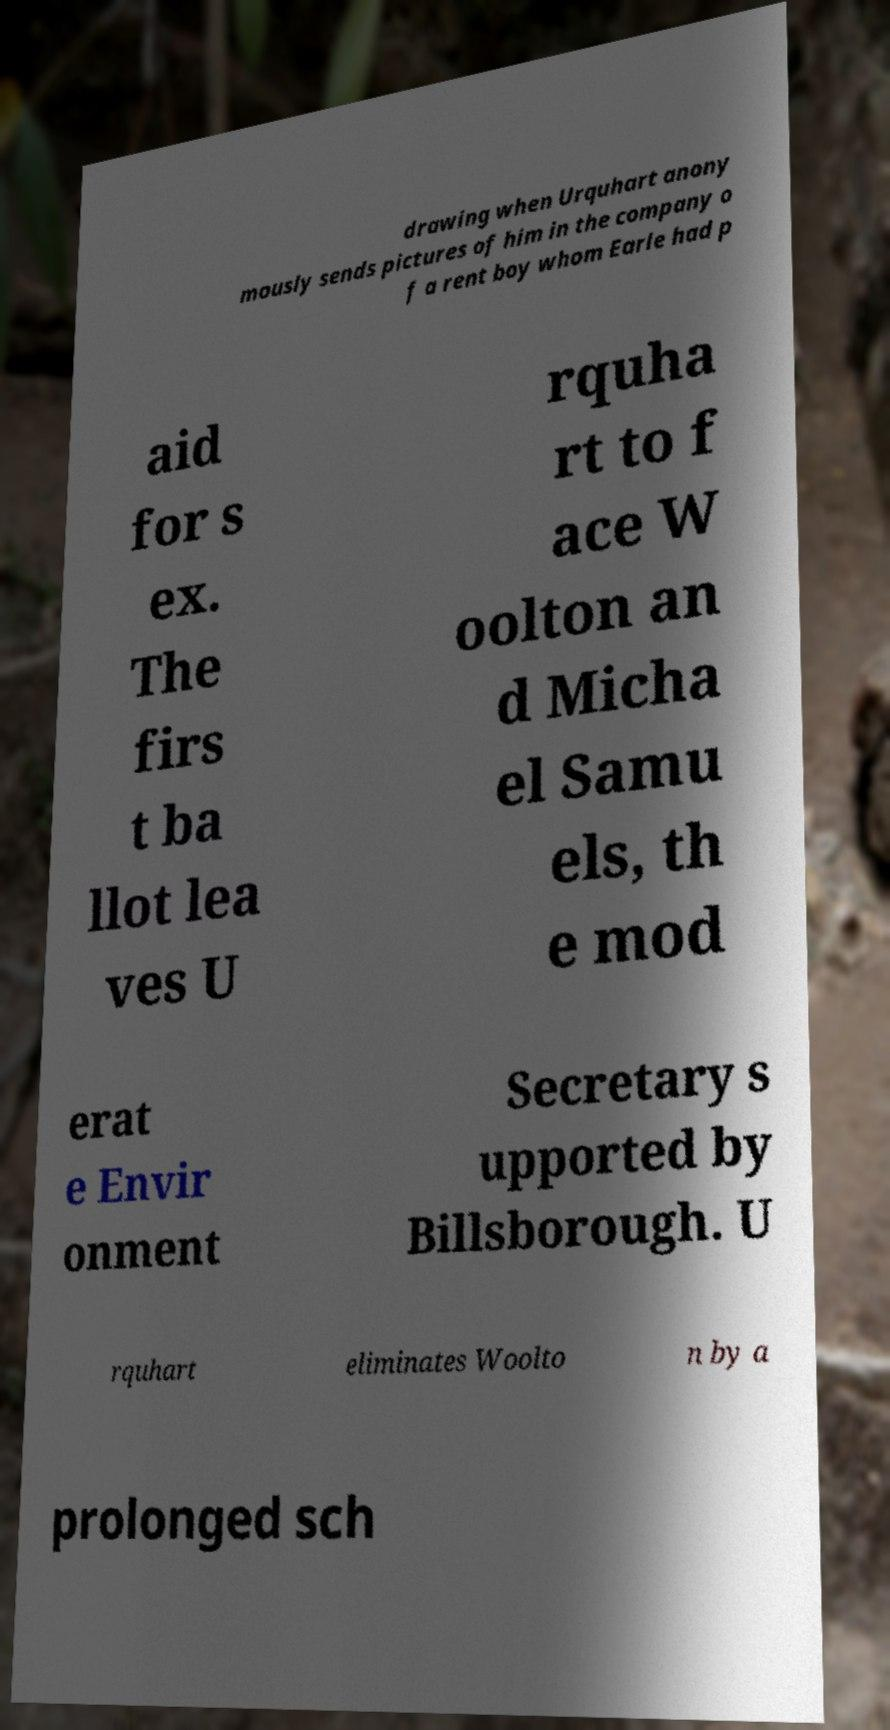Please read and relay the text visible in this image. What does it say? drawing when Urquhart anony mously sends pictures of him in the company o f a rent boy whom Earle had p aid for s ex. The firs t ba llot lea ves U rquha rt to f ace W oolton an d Micha el Samu els, th e mod erat e Envir onment Secretary s upported by Billsborough. U rquhart eliminates Woolto n by a prolonged sch 